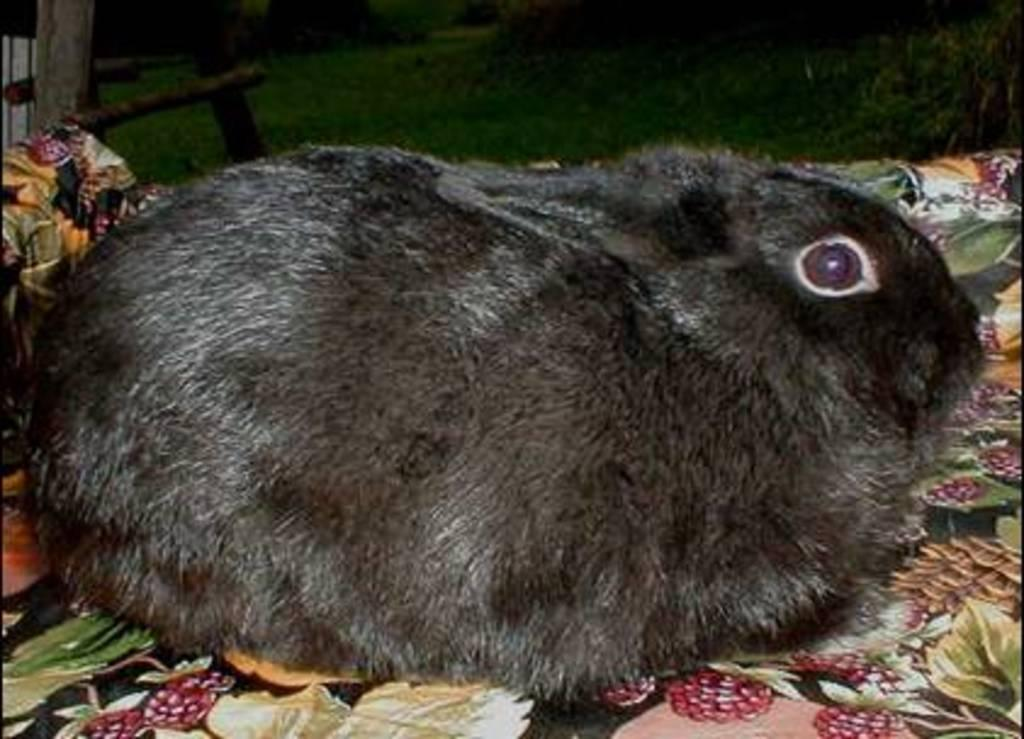What type of animal is in the image? There is a black-colored rabbit in the image. Where is the rabbit located in the image? The rabbit is in the front of the image. What can be seen in the background of the image? There is grass visible in the background of the image. What type of jeans is the rabbit wearing in the image? The rabbit is not wearing jeans in the image, as rabbits do not wear clothing. 